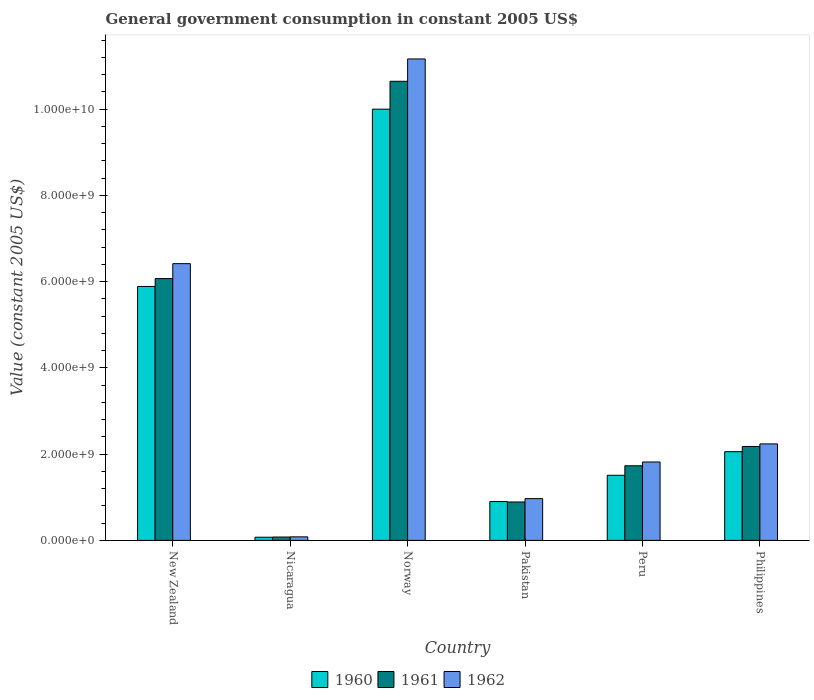How many different coloured bars are there?
Keep it short and to the point. 3. How many groups of bars are there?
Offer a terse response. 6. Are the number of bars per tick equal to the number of legend labels?
Ensure brevity in your answer.  Yes. How many bars are there on the 4th tick from the left?
Make the answer very short. 3. How many bars are there on the 4th tick from the right?
Your answer should be compact. 3. What is the government conusmption in 1960 in Nicaragua?
Offer a terse response. 7.32e+07. Across all countries, what is the maximum government conusmption in 1961?
Your answer should be compact. 1.06e+1. Across all countries, what is the minimum government conusmption in 1960?
Offer a very short reply. 7.32e+07. In which country was the government conusmption in 1962 minimum?
Provide a short and direct response. Nicaragua. What is the total government conusmption in 1961 in the graph?
Offer a terse response. 2.16e+1. What is the difference between the government conusmption in 1961 in Pakistan and that in Philippines?
Offer a terse response. -1.29e+09. What is the difference between the government conusmption in 1960 in New Zealand and the government conusmption in 1961 in Pakistan?
Make the answer very short. 5.00e+09. What is the average government conusmption in 1960 per country?
Keep it short and to the point. 3.40e+09. What is the difference between the government conusmption of/in 1961 and government conusmption of/in 1960 in Pakistan?
Ensure brevity in your answer.  -9.85e+06. What is the ratio of the government conusmption in 1960 in New Zealand to that in Pakistan?
Provide a succinct answer. 6.54. Is the government conusmption in 1960 in Norway less than that in Pakistan?
Your response must be concise. No. Is the difference between the government conusmption in 1961 in Pakistan and Peru greater than the difference between the government conusmption in 1960 in Pakistan and Peru?
Offer a very short reply. No. What is the difference between the highest and the second highest government conusmption in 1962?
Your answer should be very brief. 8.93e+09. What is the difference between the highest and the lowest government conusmption in 1961?
Provide a succinct answer. 1.06e+1. In how many countries, is the government conusmption in 1960 greater than the average government conusmption in 1960 taken over all countries?
Your answer should be very brief. 2. What does the 1st bar from the left in Pakistan represents?
Give a very brief answer. 1960. How many bars are there?
Provide a short and direct response. 18. How many countries are there in the graph?
Provide a succinct answer. 6. Are the values on the major ticks of Y-axis written in scientific E-notation?
Your response must be concise. Yes. Does the graph contain any zero values?
Keep it short and to the point. No. Does the graph contain grids?
Provide a succinct answer. No. Where does the legend appear in the graph?
Give a very brief answer. Bottom center. What is the title of the graph?
Offer a very short reply. General government consumption in constant 2005 US$. What is the label or title of the Y-axis?
Your response must be concise. Value (constant 2005 US$). What is the Value (constant 2005 US$) of 1960 in New Zealand?
Your answer should be very brief. 5.89e+09. What is the Value (constant 2005 US$) in 1961 in New Zealand?
Your answer should be very brief. 6.07e+09. What is the Value (constant 2005 US$) in 1962 in New Zealand?
Ensure brevity in your answer.  6.42e+09. What is the Value (constant 2005 US$) in 1960 in Nicaragua?
Give a very brief answer. 7.32e+07. What is the Value (constant 2005 US$) of 1961 in Nicaragua?
Provide a succinct answer. 7.81e+07. What is the Value (constant 2005 US$) in 1962 in Nicaragua?
Keep it short and to the point. 8.22e+07. What is the Value (constant 2005 US$) of 1960 in Norway?
Offer a terse response. 1.00e+1. What is the Value (constant 2005 US$) of 1961 in Norway?
Offer a very short reply. 1.06e+1. What is the Value (constant 2005 US$) in 1962 in Norway?
Offer a very short reply. 1.12e+1. What is the Value (constant 2005 US$) in 1960 in Pakistan?
Provide a short and direct response. 9.00e+08. What is the Value (constant 2005 US$) in 1961 in Pakistan?
Provide a short and direct response. 8.91e+08. What is the Value (constant 2005 US$) of 1962 in Pakistan?
Ensure brevity in your answer.  9.69e+08. What is the Value (constant 2005 US$) in 1960 in Peru?
Your answer should be compact. 1.51e+09. What is the Value (constant 2005 US$) in 1961 in Peru?
Make the answer very short. 1.73e+09. What is the Value (constant 2005 US$) of 1962 in Peru?
Your answer should be very brief. 1.82e+09. What is the Value (constant 2005 US$) in 1960 in Philippines?
Provide a succinct answer. 2.06e+09. What is the Value (constant 2005 US$) of 1961 in Philippines?
Keep it short and to the point. 2.18e+09. What is the Value (constant 2005 US$) of 1962 in Philippines?
Make the answer very short. 2.24e+09. Across all countries, what is the maximum Value (constant 2005 US$) of 1960?
Ensure brevity in your answer.  1.00e+1. Across all countries, what is the maximum Value (constant 2005 US$) in 1961?
Make the answer very short. 1.06e+1. Across all countries, what is the maximum Value (constant 2005 US$) of 1962?
Your response must be concise. 1.12e+1. Across all countries, what is the minimum Value (constant 2005 US$) of 1960?
Offer a very short reply. 7.32e+07. Across all countries, what is the minimum Value (constant 2005 US$) in 1961?
Ensure brevity in your answer.  7.81e+07. Across all countries, what is the minimum Value (constant 2005 US$) of 1962?
Ensure brevity in your answer.  8.22e+07. What is the total Value (constant 2005 US$) of 1960 in the graph?
Make the answer very short. 2.04e+1. What is the total Value (constant 2005 US$) of 1961 in the graph?
Offer a terse response. 2.16e+1. What is the total Value (constant 2005 US$) in 1962 in the graph?
Your answer should be compact. 2.27e+1. What is the difference between the Value (constant 2005 US$) in 1960 in New Zealand and that in Nicaragua?
Give a very brief answer. 5.81e+09. What is the difference between the Value (constant 2005 US$) of 1961 in New Zealand and that in Nicaragua?
Your answer should be compact. 5.99e+09. What is the difference between the Value (constant 2005 US$) in 1962 in New Zealand and that in Nicaragua?
Make the answer very short. 6.33e+09. What is the difference between the Value (constant 2005 US$) of 1960 in New Zealand and that in Norway?
Keep it short and to the point. -4.11e+09. What is the difference between the Value (constant 2005 US$) of 1961 in New Zealand and that in Norway?
Give a very brief answer. -4.57e+09. What is the difference between the Value (constant 2005 US$) of 1962 in New Zealand and that in Norway?
Offer a terse response. -4.75e+09. What is the difference between the Value (constant 2005 US$) of 1960 in New Zealand and that in Pakistan?
Provide a short and direct response. 4.99e+09. What is the difference between the Value (constant 2005 US$) of 1961 in New Zealand and that in Pakistan?
Your answer should be compact. 5.18e+09. What is the difference between the Value (constant 2005 US$) of 1962 in New Zealand and that in Pakistan?
Provide a short and direct response. 5.45e+09. What is the difference between the Value (constant 2005 US$) in 1960 in New Zealand and that in Peru?
Give a very brief answer. 4.38e+09. What is the difference between the Value (constant 2005 US$) of 1961 in New Zealand and that in Peru?
Provide a short and direct response. 4.34e+09. What is the difference between the Value (constant 2005 US$) in 1962 in New Zealand and that in Peru?
Give a very brief answer. 4.60e+09. What is the difference between the Value (constant 2005 US$) in 1960 in New Zealand and that in Philippines?
Offer a very short reply. 3.83e+09. What is the difference between the Value (constant 2005 US$) in 1961 in New Zealand and that in Philippines?
Make the answer very short. 3.89e+09. What is the difference between the Value (constant 2005 US$) of 1962 in New Zealand and that in Philippines?
Give a very brief answer. 4.18e+09. What is the difference between the Value (constant 2005 US$) of 1960 in Nicaragua and that in Norway?
Offer a terse response. -9.92e+09. What is the difference between the Value (constant 2005 US$) in 1961 in Nicaragua and that in Norway?
Keep it short and to the point. -1.06e+1. What is the difference between the Value (constant 2005 US$) of 1962 in Nicaragua and that in Norway?
Provide a succinct answer. -1.11e+1. What is the difference between the Value (constant 2005 US$) in 1960 in Nicaragua and that in Pakistan?
Your answer should be compact. -8.27e+08. What is the difference between the Value (constant 2005 US$) in 1961 in Nicaragua and that in Pakistan?
Provide a short and direct response. -8.12e+08. What is the difference between the Value (constant 2005 US$) in 1962 in Nicaragua and that in Pakistan?
Give a very brief answer. -8.86e+08. What is the difference between the Value (constant 2005 US$) in 1960 in Nicaragua and that in Peru?
Your answer should be compact. -1.44e+09. What is the difference between the Value (constant 2005 US$) in 1961 in Nicaragua and that in Peru?
Offer a very short reply. -1.65e+09. What is the difference between the Value (constant 2005 US$) in 1962 in Nicaragua and that in Peru?
Give a very brief answer. -1.74e+09. What is the difference between the Value (constant 2005 US$) of 1960 in Nicaragua and that in Philippines?
Give a very brief answer. -1.98e+09. What is the difference between the Value (constant 2005 US$) in 1961 in Nicaragua and that in Philippines?
Provide a succinct answer. -2.10e+09. What is the difference between the Value (constant 2005 US$) of 1962 in Nicaragua and that in Philippines?
Your answer should be very brief. -2.15e+09. What is the difference between the Value (constant 2005 US$) in 1960 in Norway and that in Pakistan?
Provide a short and direct response. 9.10e+09. What is the difference between the Value (constant 2005 US$) in 1961 in Norway and that in Pakistan?
Your response must be concise. 9.75e+09. What is the difference between the Value (constant 2005 US$) in 1962 in Norway and that in Pakistan?
Your response must be concise. 1.02e+1. What is the difference between the Value (constant 2005 US$) of 1960 in Norway and that in Peru?
Provide a succinct answer. 8.49e+09. What is the difference between the Value (constant 2005 US$) of 1961 in Norway and that in Peru?
Keep it short and to the point. 8.91e+09. What is the difference between the Value (constant 2005 US$) of 1962 in Norway and that in Peru?
Ensure brevity in your answer.  9.34e+09. What is the difference between the Value (constant 2005 US$) of 1960 in Norway and that in Philippines?
Offer a very short reply. 7.94e+09. What is the difference between the Value (constant 2005 US$) in 1961 in Norway and that in Philippines?
Provide a succinct answer. 8.47e+09. What is the difference between the Value (constant 2005 US$) of 1962 in Norway and that in Philippines?
Provide a short and direct response. 8.93e+09. What is the difference between the Value (constant 2005 US$) in 1960 in Pakistan and that in Peru?
Ensure brevity in your answer.  -6.09e+08. What is the difference between the Value (constant 2005 US$) in 1961 in Pakistan and that in Peru?
Provide a short and direct response. -8.39e+08. What is the difference between the Value (constant 2005 US$) of 1962 in Pakistan and that in Peru?
Give a very brief answer. -8.49e+08. What is the difference between the Value (constant 2005 US$) of 1960 in Pakistan and that in Philippines?
Your answer should be very brief. -1.16e+09. What is the difference between the Value (constant 2005 US$) in 1961 in Pakistan and that in Philippines?
Give a very brief answer. -1.29e+09. What is the difference between the Value (constant 2005 US$) in 1962 in Pakistan and that in Philippines?
Your response must be concise. -1.27e+09. What is the difference between the Value (constant 2005 US$) in 1960 in Peru and that in Philippines?
Your response must be concise. -5.47e+08. What is the difference between the Value (constant 2005 US$) in 1961 in Peru and that in Philippines?
Ensure brevity in your answer.  -4.48e+08. What is the difference between the Value (constant 2005 US$) of 1962 in Peru and that in Philippines?
Offer a very short reply. -4.19e+08. What is the difference between the Value (constant 2005 US$) of 1960 in New Zealand and the Value (constant 2005 US$) of 1961 in Nicaragua?
Keep it short and to the point. 5.81e+09. What is the difference between the Value (constant 2005 US$) of 1960 in New Zealand and the Value (constant 2005 US$) of 1962 in Nicaragua?
Offer a very short reply. 5.81e+09. What is the difference between the Value (constant 2005 US$) in 1961 in New Zealand and the Value (constant 2005 US$) in 1962 in Nicaragua?
Ensure brevity in your answer.  5.99e+09. What is the difference between the Value (constant 2005 US$) in 1960 in New Zealand and the Value (constant 2005 US$) in 1961 in Norway?
Make the answer very short. -4.76e+09. What is the difference between the Value (constant 2005 US$) in 1960 in New Zealand and the Value (constant 2005 US$) in 1962 in Norway?
Your answer should be very brief. -5.27e+09. What is the difference between the Value (constant 2005 US$) in 1961 in New Zealand and the Value (constant 2005 US$) in 1962 in Norway?
Provide a succinct answer. -5.09e+09. What is the difference between the Value (constant 2005 US$) of 1960 in New Zealand and the Value (constant 2005 US$) of 1961 in Pakistan?
Your answer should be very brief. 5.00e+09. What is the difference between the Value (constant 2005 US$) of 1960 in New Zealand and the Value (constant 2005 US$) of 1962 in Pakistan?
Your response must be concise. 4.92e+09. What is the difference between the Value (constant 2005 US$) in 1961 in New Zealand and the Value (constant 2005 US$) in 1962 in Pakistan?
Give a very brief answer. 5.10e+09. What is the difference between the Value (constant 2005 US$) of 1960 in New Zealand and the Value (constant 2005 US$) of 1961 in Peru?
Your answer should be very brief. 4.16e+09. What is the difference between the Value (constant 2005 US$) in 1960 in New Zealand and the Value (constant 2005 US$) in 1962 in Peru?
Ensure brevity in your answer.  4.07e+09. What is the difference between the Value (constant 2005 US$) of 1961 in New Zealand and the Value (constant 2005 US$) of 1962 in Peru?
Keep it short and to the point. 4.25e+09. What is the difference between the Value (constant 2005 US$) in 1960 in New Zealand and the Value (constant 2005 US$) in 1961 in Philippines?
Keep it short and to the point. 3.71e+09. What is the difference between the Value (constant 2005 US$) in 1960 in New Zealand and the Value (constant 2005 US$) in 1962 in Philippines?
Make the answer very short. 3.65e+09. What is the difference between the Value (constant 2005 US$) of 1961 in New Zealand and the Value (constant 2005 US$) of 1962 in Philippines?
Keep it short and to the point. 3.83e+09. What is the difference between the Value (constant 2005 US$) in 1960 in Nicaragua and the Value (constant 2005 US$) in 1961 in Norway?
Your answer should be compact. -1.06e+1. What is the difference between the Value (constant 2005 US$) in 1960 in Nicaragua and the Value (constant 2005 US$) in 1962 in Norway?
Make the answer very short. -1.11e+1. What is the difference between the Value (constant 2005 US$) in 1961 in Nicaragua and the Value (constant 2005 US$) in 1962 in Norway?
Offer a terse response. -1.11e+1. What is the difference between the Value (constant 2005 US$) of 1960 in Nicaragua and the Value (constant 2005 US$) of 1961 in Pakistan?
Your answer should be very brief. -8.17e+08. What is the difference between the Value (constant 2005 US$) of 1960 in Nicaragua and the Value (constant 2005 US$) of 1962 in Pakistan?
Offer a very short reply. -8.95e+08. What is the difference between the Value (constant 2005 US$) in 1961 in Nicaragua and the Value (constant 2005 US$) in 1962 in Pakistan?
Make the answer very short. -8.90e+08. What is the difference between the Value (constant 2005 US$) in 1960 in Nicaragua and the Value (constant 2005 US$) in 1961 in Peru?
Keep it short and to the point. -1.66e+09. What is the difference between the Value (constant 2005 US$) in 1960 in Nicaragua and the Value (constant 2005 US$) in 1962 in Peru?
Keep it short and to the point. -1.74e+09. What is the difference between the Value (constant 2005 US$) in 1961 in Nicaragua and the Value (constant 2005 US$) in 1962 in Peru?
Provide a succinct answer. -1.74e+09. What is the difference between the Value (constant 2005 US$) of 1960 in Nicaragua and the Value (constant 2005 US$) of 1961 in Philippines?
Offer a very short reply. -2.10e+09. What is the difference between the Value (constant 2005 US$) in 1960 in Nicaragua and the Value (constant 2005 US$) in 1962 in Philippines?
Give a very brief answer. -2.16e+09. What is the difference between the Value (constant 2005 US$) in 1961 in Nicaragua and the Value (constant 2005 US$) in 1962 in Philippines?
Give a very brief answer. -2.16e+09. What is the difference between the Value (constant 2005 US$) of 1960 in Norway and the Value (constant 2005 US$) of 1961 in Pakistan?
Keep it short and to the point. 9.11e+09. What is the difference between the Value (constant 2005 US$) of 1960 in Norway and the Value (constant 2005 US$) of 1962 in Pakistan?
Provide a short and direct response. 9.03e+09. What is the difference between the Value (constant 2005 US$) of 1961 in Norway and the Value (constant 2005 US$) of 1962 in Pakistan?
Give a very brief answer. 9.68e+09. What is the difference between the Value (constant 2005 US$) in 1960 in Norway and the Value (constant 2005 US$) in 1961 in Peru?
Your answer should be very brief. 8.27e+09. What is the difference between the Value (constant 2005 US$) in 1960 in Norway and the Value (constant 2005 US$) in 1962 in Peru?
Offer a very short reply. 8.18e+09. What is the difference between the Value (constant 2005 US$) of 1961 in Norway and the Value (constant 2005 US$) of 1962 in Peru?
Offer a very short reply. 8.83e+09. What is the difference between the Value (constant 2005 US$) of 1960 in Norway and the Value (constant 2005 US$) of 1961 in Philippines?
Provide a short and direct response. 7.82e+09. What is the difference between the Value (constant 2005 US$) of 1960 in Norway and the Value (constant 2005 US$) of 1962 in Philippines?
Your answer should be very brief. 7.76e+09. What is the difference between the Value (constant 2005 US$) of 1961 in Norway and the Value (constant 2005 US$) of 1962 in Philippines?
Offer a terse response. 8.41e+09. What is the difference between the Value (constant 2005 US$) of 1960 in Pakistan and the Value (constant 2005 US$) of 1961 in Peru?
Your answer should be very brief. -8.30e+08. What is the difference between the Value (constant 2005 US$) in 1960 in Pakistan and the Value (constant 2005 US$) in 1962 in Peru?
Ensure brevity in your answer.  -9.18e+08. What is the difference between the Value (constant 2005 US$) in 1961 in Pakistan and the Value (constant 2005 US$) in 1962 in Peru?
Make the answer very short. -9.27e+08. What is the difference between the Value (constant 2005 US$) in 1960 in Pakistan and the Value (constant 2005 US$) in 1961 in Philippines?
Give a very brief answer. -1.28e+09. What is the difference between the Value (constant 2005 US$) of 1960 in Pakistan and the Value (constant 2005 US$) of 1962 in Philippines?
Keep it short and to the point. -1.34e+09. What is the difference between the Value (constant 2005 US$) of 1961 in Pakistan and the Value (constant 2005 US$) of 1962 in Philippines?
Give a very brief answer. -1.35e+09. What is the difference between the Value (constant 2005 US$) of 1960 in Peru and the Value (constant 2005 US$) of 1961 in Philippines?
Provide a short and direct response. -6.68e+08. What is the difference between the Value (constant 2005 US$) of 1960 in Peru and the Value (constant 2005 US$) of 1962 in Philippines?
Your answer should be compact. -7.27e+08. What is the difference between the Value (constant 2005 US$) in 1961 in Peru and the Value (constant 2005 US$) in 1962 in Philippines?
Make the answer very short. -5.07e+08. What is the average Value (constant 2005 US$) in 1960 per country?
Provide a short and direct response. 3.40e+09. What is the average Value (constant 2005 US$) of 1961 per country?
Make the answer very short. 3.60e+09. What is the average Value (constant 2005 US$) in 1962 per country?
Provide a short and direct response. 3.78e+09. What is the difference between the Value (constant 2005 US$) of 1960 and Value (constant 2005 US$) of 1961 in New Zealand?
Provide a short and direct response. -1.82e+08. What is the difference between the Value (constant 2005 US$) of 1960 and Value (constant 2005 US$) of 1962 in New Zealand?
Provide a succinct answer. -5.28e+08. What is the difference between the Value (constant 2005 US$) in 1961 and Value (constant 2005 US$) in 1962 in New Zealand?
Keep it short and to the point. -3.46e+08. What is the difference between the Value (constant 2005 US$) of 1960 and Value (constant 2005 US$) of 1961 in Nicaragua?
Provide a short and direct response. -4.90e+06. What is the difference between the Value (constant 2005 US$) of 1960 and Value (constant 2005 US$) of 1962 in Nicaragua?
Make the answer very short. -8.94e+06. What is the difference between the Value (constant 2005 US$) of 1961 and Value (constant 2005 US$) of 1962 in Nicaragua?
Ensure brevity in your answer.  -4.04e+06. What is the difference between the Value (constant 2005 US$) in 1960 and Value (constant 2005 US$) in 1961 in Norway?
Keep it short and to the point. -6.46e+08. What is the difference between the Value (constant 2005 US$) in 1960 and Value (constant 2005 US$) in 1962 in Norway?
Your response must be concise. -1.16e+09. What is the difference between the Value (constant 2005 US$) of 1961 and Value (constant 2005 US$) of 1962 in Norway?
Offer a very short reply. -5.18e+08. What is the difference between the Value (constant 2005 US$) in 1960 and Value (constant 2005 US$) in 1961 in Pakistan?
Offer a very short reply. 9.85e+06. What is the difference between the Value (constant 2005 US$) in 1960 and Value (constant 2005 US$) in 1962 in Pakistan?
Ensure brevity in your answer.  -6.81e+07. What is the difference between the Value (constant 2005 US$) in 1961 and Value (constant 2005 US$) in 1962 in Pakistan?
Offer a very short reply. -7.80e+07. What is the difference between the Value (constant 2005 US$) of 1960 and Value (constant 2005 US$) of 1961 in Peru?
Keep it short and to the point. -2.20e+08. What is the difference between the Value (constant 2005 US$) in 1960 and Value (constant 2005 US$) in 1962 in Peru?
Give a very brief answer. -3.08e+08. What is the difference between the Value (constant 2005 US$) of 1961 and Value (constant 2005 US$) of 1962 in Peru?
Make the answer very short. -8.81e+07. What is the difference between the Value (constant 2005 US$) in 1960 and Value (constant 2005 US$) in 1961 in Philippines?
Give a very brief answer. -1.21e+08. What is the difference between the Value (constant 2005 US$) of 1960 and Value (constant 2005 US$) of 1962 in Philippines?
Provide a succinct answer. -1.81e+08. What is the difference between the Value (constant 2005 US$) in 1961 and Value (constant 2005 US$) in 1962 in Philippines?
Offer a very short reply. -5.93e+07. What is the ratio of the Value (constant 2005 US$) of 1960 in New Zealand to that in Nicaragua?
Keep it short and to the point. 80.4. What is the ratio of the Value (constant 2005 US$) in 1961 in New Zealand to that in Nicaragua?
Your answer should be compact. 77.68. What is the ratio of the Value (constant 2005 US$) of 1962 in New Zealand to that in Nicaragua?
Give a very brief answer. 78.08. What is the ratio of the Value (constant 2005 US$) in 1960 in New Zealand to that in Norway?
Make the answer very short. 0.59. What is the ratio of the Value (constant 2005 US$) in 1961 in New Zealand to that in Norway?
Make the answer very short. 0.57. What is the ratio of the Value (constant 2005 US$) of 1962 in New Zealand to that in Norway?
Your answer should be very brief. 0.57. What is the ratio of the Value (constant 2005 US$) of 1960 in New Zealand to that in Pakistan?
Provide a short and direct response. 6.54. What is the ratio of the Value (constant 2005 US$) of 1961 in New Zealand to that in Pakistan?
Your response must be concise. 6.82. What is the ratio of the Value (constant 2005 US$) of 1962 in New Zealand to that in Pakistan?
Ensure brevity in your answer.  6.62. What is the ratio of the Value (constant 2005 US$) in 1960 in New Zealand to that in Peru?
Offer a very short reply. 3.9. What is the ratio of the Value (constant 2005 US$) of 1961 in New Zealand to that in Peru?
Your response must be concise. 3.51. What is the ratio of the Value (constant 2005 US$) of 1962 in New Zealand to that in Peru?
Your answer should be very brief. 3.53. What is the ratio of the Value (constant 2005 US$) of 1960 in New Zealand to that in Philippines?
Provide a short and direct response. 2.86. What is the ratio of the Value (constant 2005 US$) of 1961 in New Zealand to that in Philippines?
Provide a short and direct response. 2.79. What is the ratio of the Value (constant 2005 US$) in 1962 in New Zealand to that in Philippines?
Provide a short and direct response. 2.87. What is the ratio of the Value (constant 2005 US$) of 1960 in Nicaragua to that in Norway?
Keep it short and to the point. 0.01. What is the ratio of the Value (constant 2005 US$) of 1961 in Nicaragua to that in Norway?
Make the answer very short. 0.01. What is the ratio of the Value (constant 2005 US$) of 1962 in Nicaragua to that in Norway?
Your answer should be very brief. 0.01. What is the ratio of the Value (constant 2005 US$) in 1960 in Nicaragua to that in Pakistan?
Provide a succinct answer. 0.08. What is the ratio of the Value (constant 2005 US$) of 1961 in Nicaragua to that in Pakistan?
Offer a terse response. 0.09. What is the ratio of the Value (constant 2005 US$) of 1962 in Nicaragua to that in Pakistan?
Provide a short and direct response. 0.08. What is the ratio of the Value (constant 2005 US$) of 1960 in Nicaragua to that in Peru?
Your answer should be very brief. 0.05. What is the ratio of the Value (constant 2005 US$) in 1961 in Nicaragua to that in Peru?
Offer a very short reply. 0.05. What is the ratio of the Value (constant 2005 US$) in 1962 in Nicaragua to that in Peru?
Make the answer very short. 0.05. What is the ratio of the Value (constant 2005 US$) in 1960 in Nicaragua to that in Philippines?
Ensure brevity in your answer.  0.04. What is the ratio of the Value (constant 2005 US$) in 1961 in Nicaragua to that in Philippines?
Make the answer very short. 0.04. What is the ratio of the Value (constant 2005 US$) in 1962 in Nicaragua to that in Philippines?
Offer a terse response. 0.04. What is the ratio of the Value (constant 2005 US$) in 1960 in Norway to that in Pakistan?
Keep it short and to the point. 11.1. What is the ratio of the Value (constant 2005 US$) in 1961 in Norway to that in Pakistan?
Provide a succinct answer. 11.95. What is the ratio of the Value (constant 2005 US$) in 1962 in Norway to that in Pakistan?
Keep it short and to the point. 11.52. What is the ratio of the Value (constant 2005 US$) of 1960 in Norway to that in Peru?
Offer a terse response. 6.62. What is the ratio of the Value (constant 2005 US$) in 1961 in Norway to that in Peru?
Provide a short and direct response. 6.15. What is the ratio of the Value (constant 2005 US$) in 1962 in Norway to that in Peru?
Provide a succinct answer. 6.14. What is the ratio of the Value (constant 2005 US$) in 1960 in Norway to that in Philippines?
Provide a short and direct response. 4.86. What is the ratio of the Value (constant 2005 US$) in 1961 in Norway to that in Philippines?
Offer a terse response. 4.89. What is the ratio of the Value (constant 2005 US$) in 1962 in Norway to that in Philippines?
Provide a succinct answer. 4.99. What is the ratio of the Value (constant 2005 US$) of 1960 in Pakistan to that in Peru?
Keep it short and to the point. 0.6. What is the ratio of the Value (constant 2005 US$) in 1961 in Pakistan to that in Peru?
Your answer should be compact. 0.51. What is the ratio of the Value (constant 2005 US$) of 1962 in Pakistan to that in Peru?
Offer a very short reply. 0.53. What is the ratio of the Value (constant 2005 US$) in 1960 in Pakistan to that in Philippines?
Make the answer very short. 0.44. What is the ratio of the Value (constant 2005 US$) in 1961 in Pakistan to that in Philippines?
Provide a succinct answer. 0.41. What is the ratio of the Value (constant 2005 US$) of 1962 in Pakistan to that in Philippines?
Keep it short and to the point. 0.43. What is the ratio of the Value (constant 2005 US$) in 1960 in Peru to that in Philippines?
Your answer should be compact. 0.73. What is the ratio of the Value (constant 2005 US$) in 1961 in Peru to that in Philippines?
Your answer should be very brief. 0.79. What is the ratio of the Value (constant 2005 US$) of 1962 in Peru to that in Philippines?
Offer a terse response. 0.81. What is the difference between the highest and the second highest Value (constant 2005 US$) of 1960?
Make the answer very short. 4.11e+09. What is the difference between the highest and the second highest Value (constant 2005 US$) in 1961?
Offer a very short reply. 4.57e+09. What is the difference between the highest and the second highest Value (constant 2005 US$) in 1962?
Offer a very short reply. 4.75e+09. What is the difference between the highest and the lowest Value (constant 2005 US$) in 1960?
Your response must be concise. 9.92e+09. What is the difference between the highest and the lowest Value (constant 2005 US$) of 1961?
Your answer should be very brief. 1.06e+1. What is the difference between the highest and the lowest Value (constant 2005 US$) of 1962?
Your answer should be compact. 1.11e+1. 